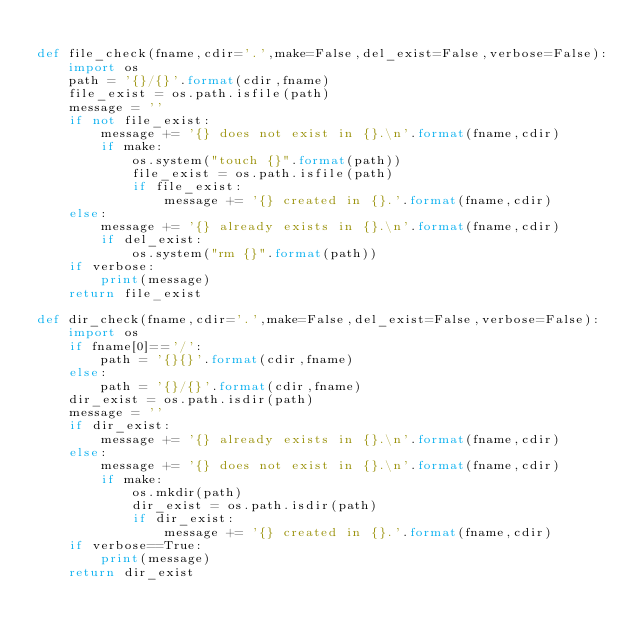<code> <loc_0><loc_0><loc_500><loc_500><_Python_>
def file_check(fname,cdir='.',make=False,del_exist=False,verbose=False):
	import os
	path = '{}/{}'.format(cdir,fname)
	file_exist = os.path.isfile(path)
	message = ''
	if not file_exist:
		message += '{} does not exist in {}.\n'.format(fname,cdir)
		if make:
			os.system("touch {}".format(path))
			file_exist = os.path.isfile(path)
			if file_exist:
				message += '{} created in {}.'.format(fname,cdir)
	else:
		message += '{} already exists in {}.\n'.format(fname,cdir)
		if del_exist:
			os.system("rm {}".format(path))
	if verbose:
		print(message)
	return file_exist

def dir_check(fname,cdir='.',make=False,del_exist=False,verbose=False):
	import os
	if fname[0]=='/':
		path = '{}{}'.format(cdir,fname)
	else:
		path = '{}/{}'.format(cdir,fname)
	dir_exist = os.path.isdir(path)
	message = ''
	if dir_exist:
		message += '{} already exists in {}.\n'.format(fname,cdir)		
	else:
		message += '{} does not exist in {}.\n'.format(fname,cdir)
		if make:
			os.mkdir(path)
			dir_exist = os.path.isdir(path)
			if dir_exist:
				message += '{} created in {}.'.format(fname,cdir)
	if verbose==True:
		print(message)
	return dir_exist

</code> 